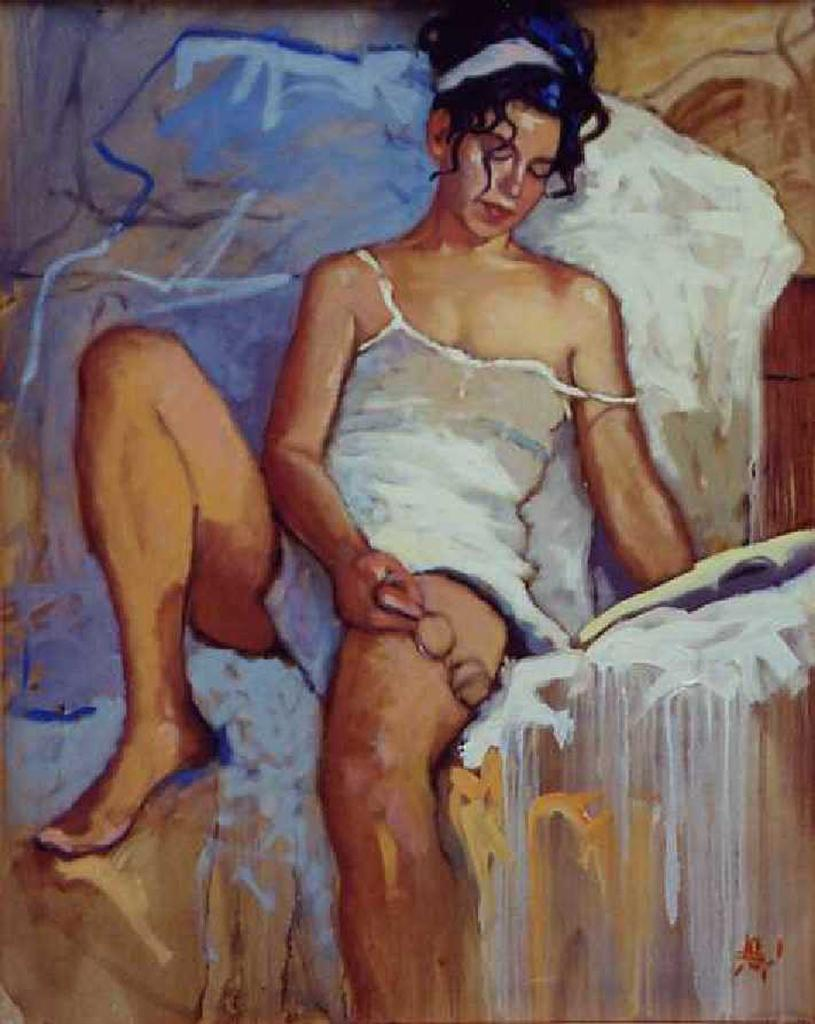What is the main subject of the image? There is a painting in the image. What is the painting depicting? The painting depicts a woman. What is the woman holding in the painting? The woman is holding spectacles. What type of quartz can be seen in the painting? There is no quartz present in the painting; it features a woman holding spectacles. Is there a shop visible in the painting? The painting does not depict a shop; it focuses on a woman holding spectacles. 